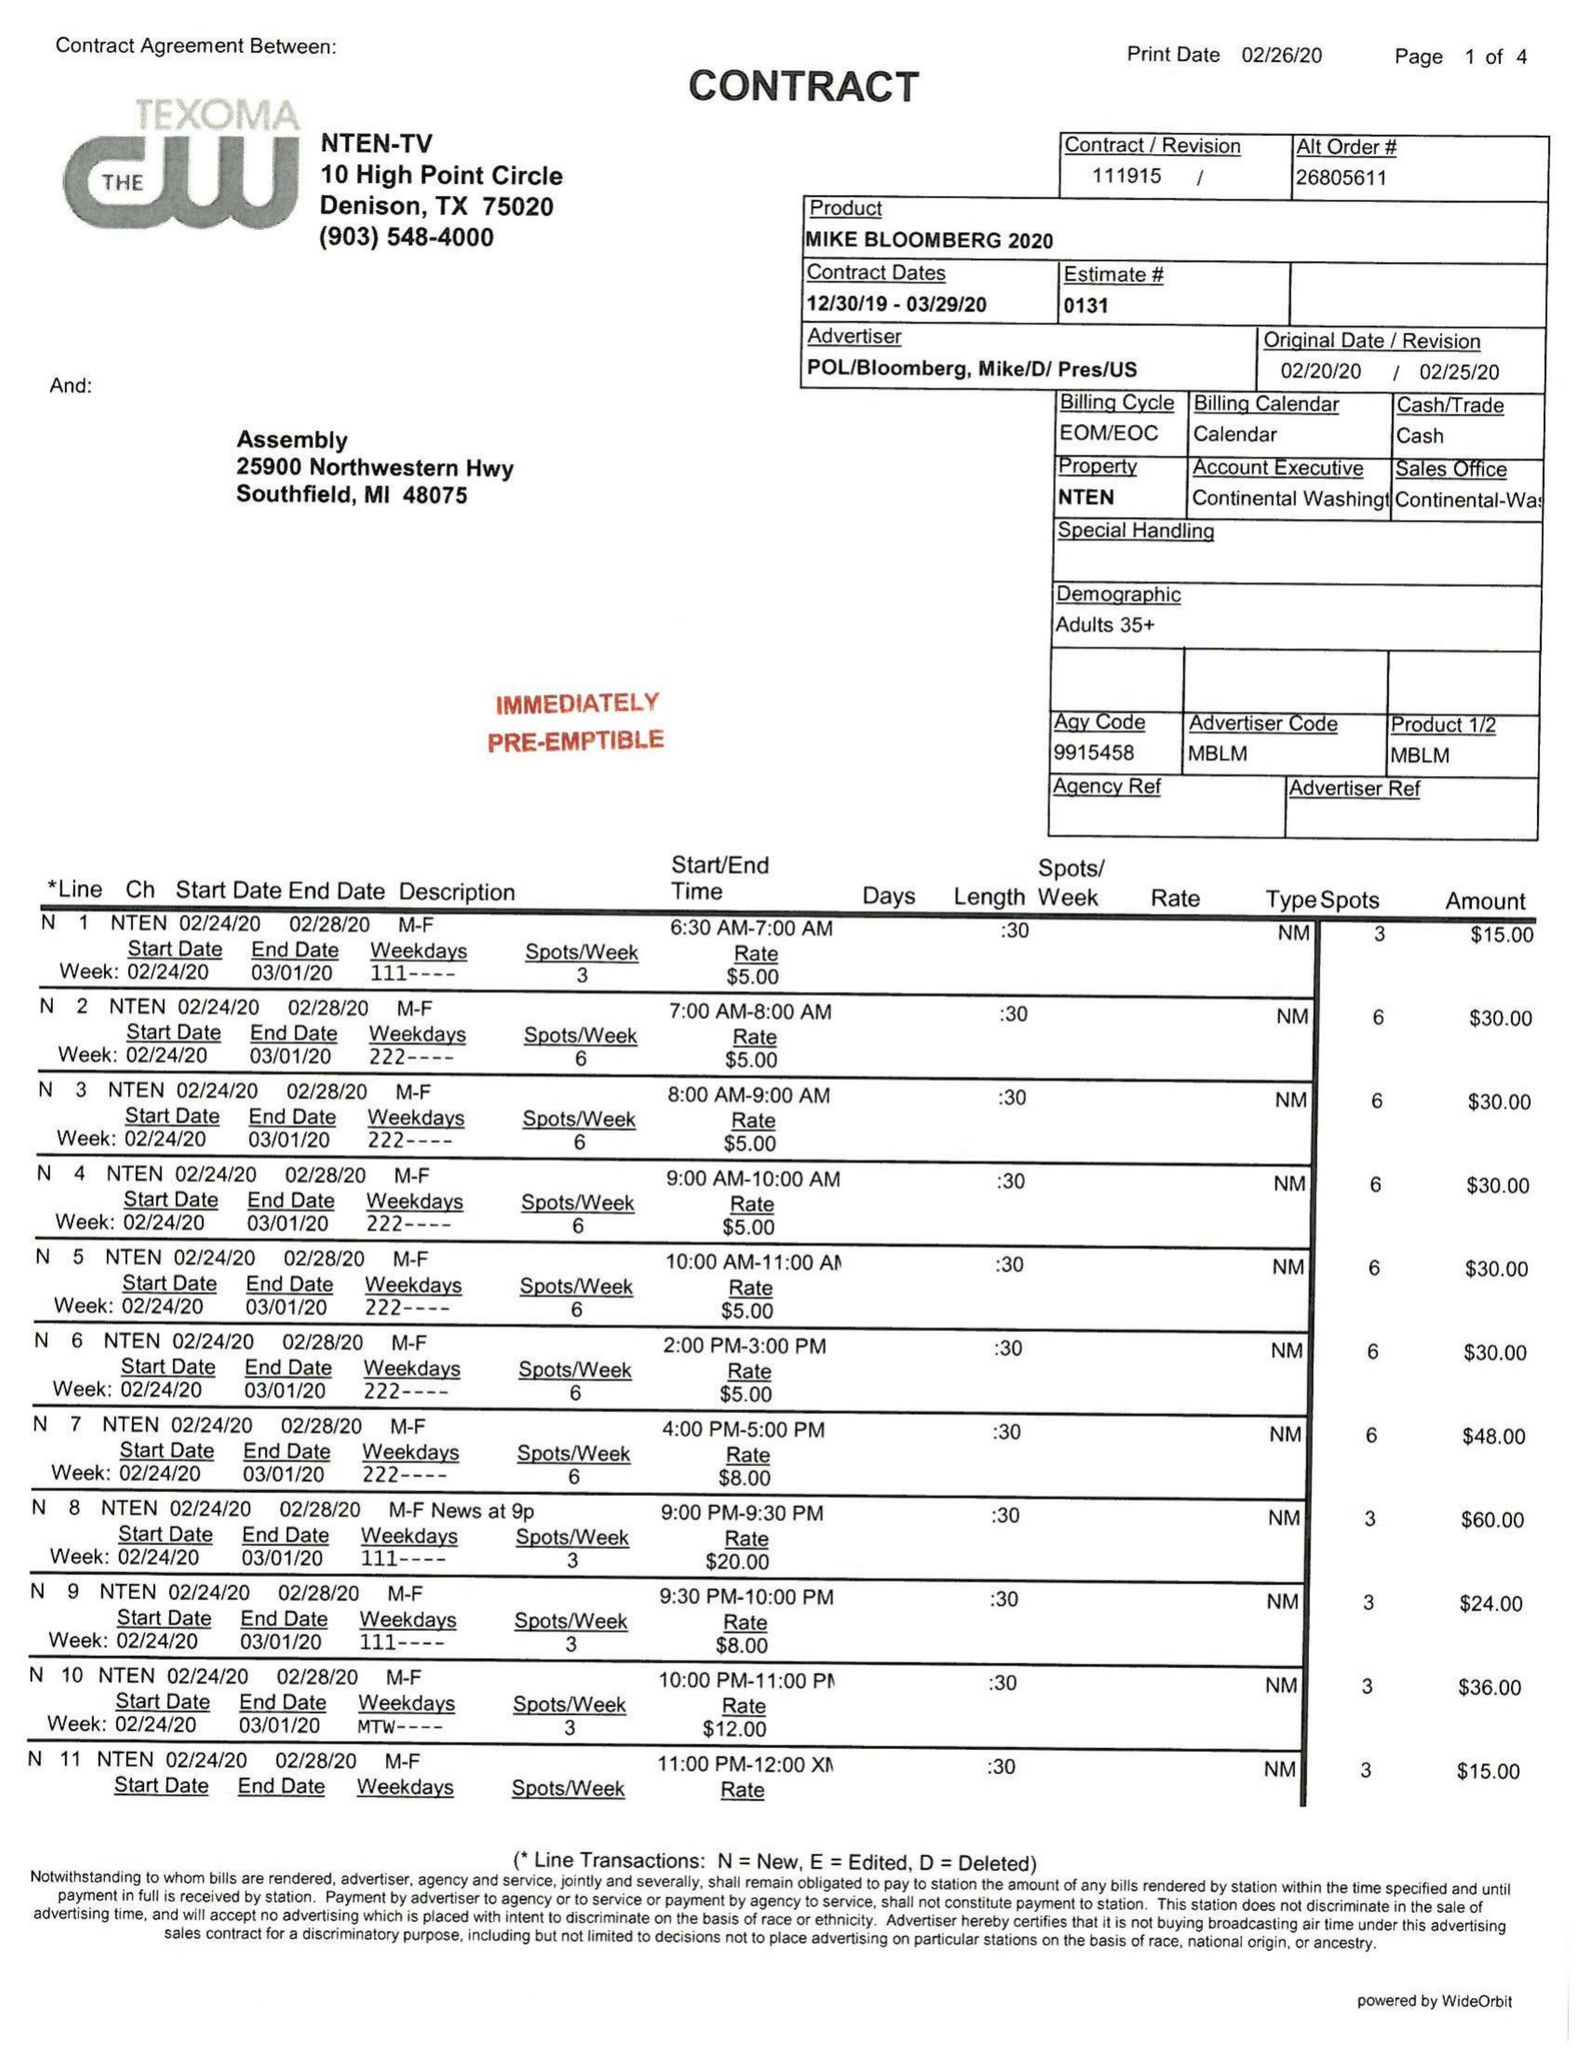What is the value for the advertiser?
Answer the question using a single word or phrase. POL/BLOOMBERG,MIKE/D/PRES/US 